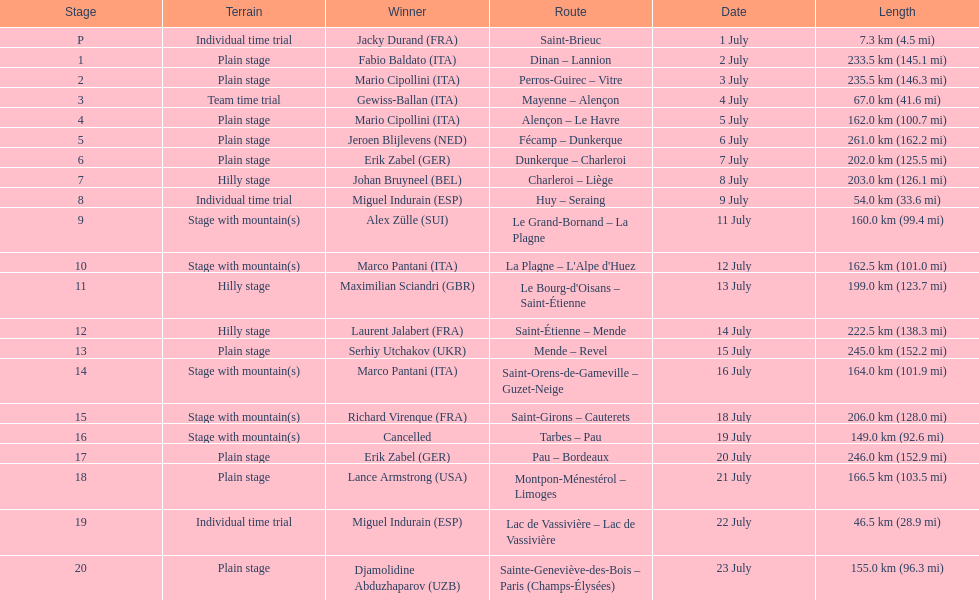How many routes have below 100 km total? 4. 